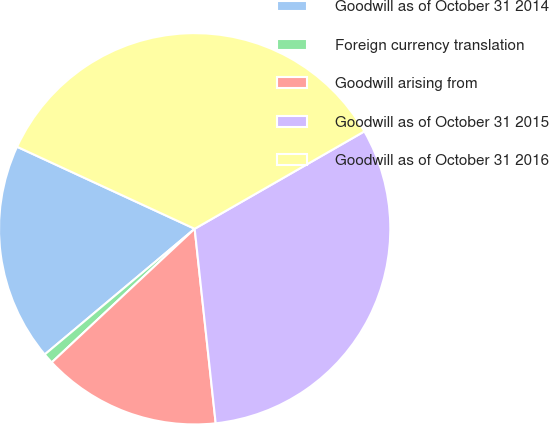<chart> <loc_0><loc_0><loc_500><loc_500><pie_chart><fcel>Goodwill as of October 31 2014<fcel>Foreign currency translation<fcel>Goodwill arising from<fcel>Goodwill as of October 31 2015<fcel>Goodwill as of October 31 2016<nl><fcel>17.99%<fcel>0.86%<fcel>14.75%<fcel>31.58%<fcel>34.82%<nl></chart> 